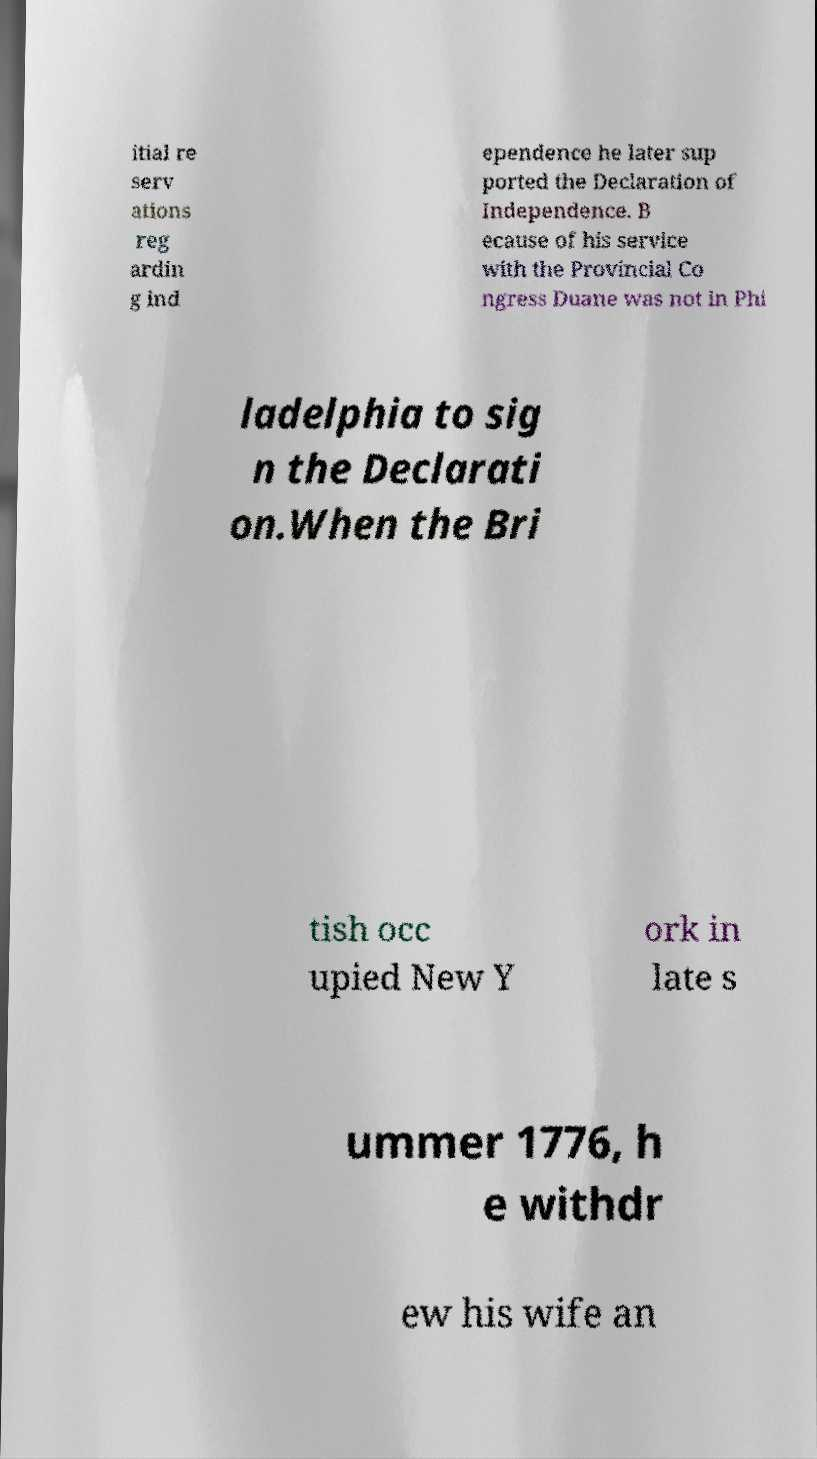Could you assist in decoding the text presented in this image and type it out clearly? itial re serv ations reg ardin g ind ependence he later sup ported the Declaration of Independence. B ecause of his service with the Provincial Co ngress Duane was not in Phi ladelphia to sig n the Declarati on.When the Bri tish occ upied New Y ork in late s ummer 1776, h e withdr ew his wife an 